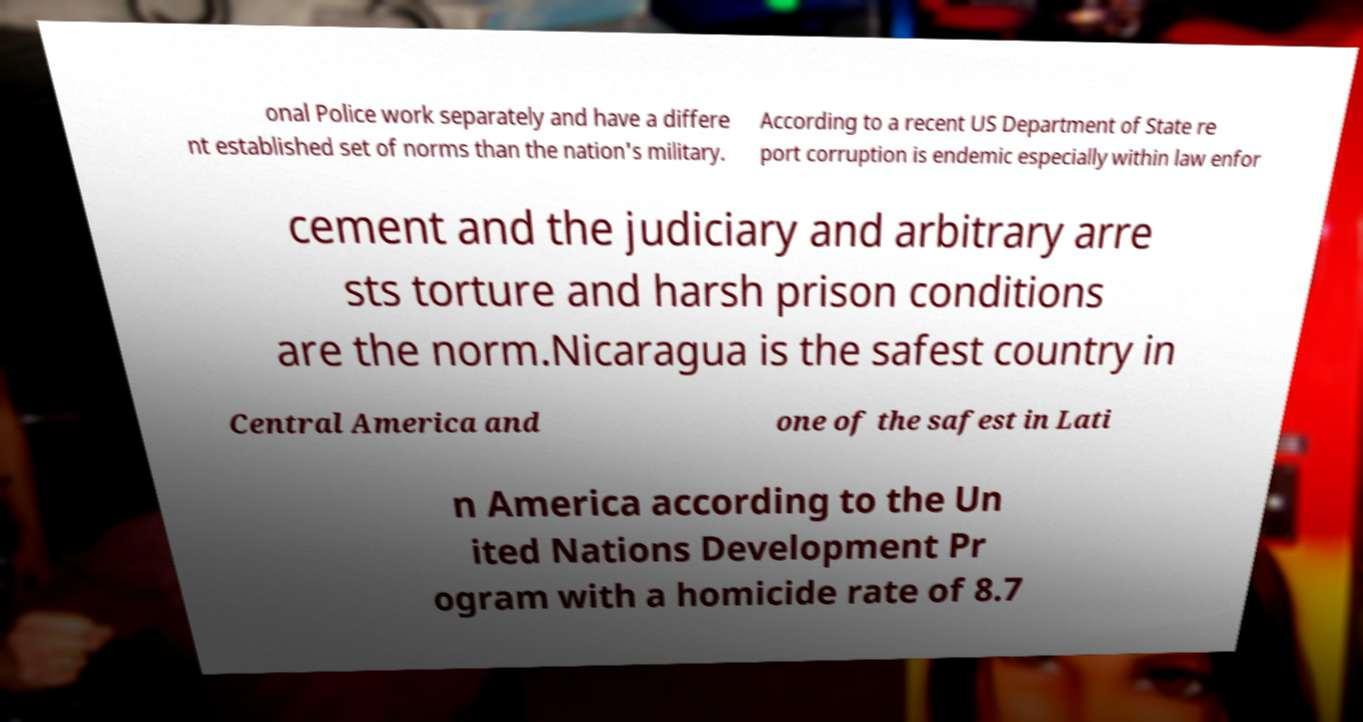Please read and relay the text visible in this image. What does it say? onal Police work separately and have a differe nt established set of norms than the nation's military. According to a recent US Department of State re port corruption is endemic especially within law enfor cement and the judiciary and arbitrary arre sts torture and harsh prison conditions are the norm.Nicaragua is the safest country in Central America and one of the safest in Lati n America according to the Un ited Nations Development Pr ogram with a homicide rate of 8.7 